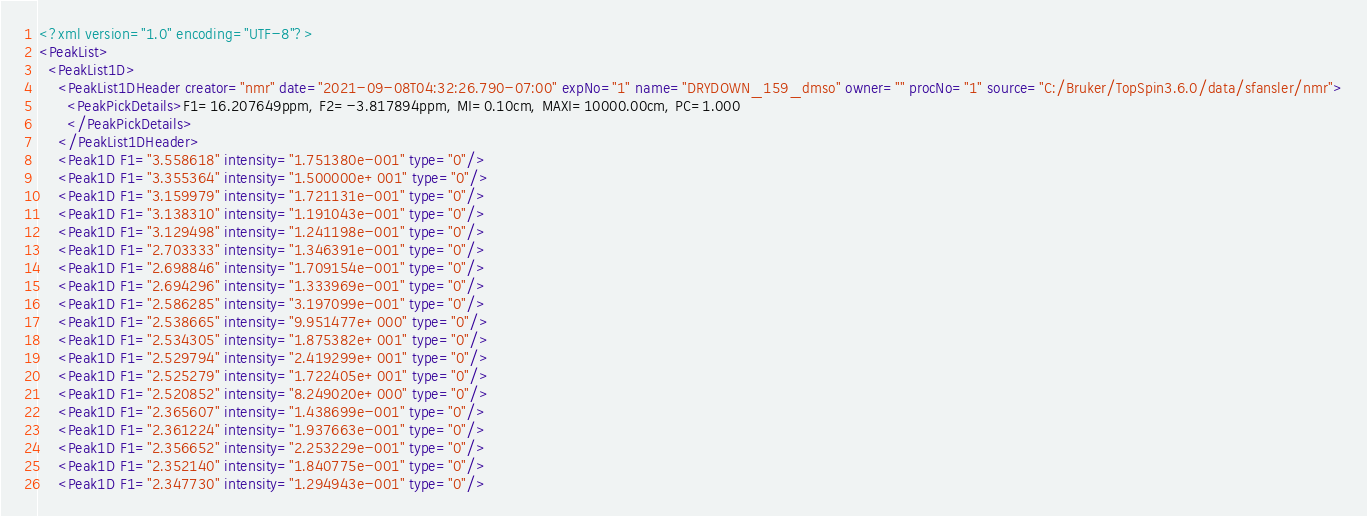Convert code to text. <code><loc_0><loc_0><loc_500><loc_500><_XML_><?xml version="1.0" encoding="UTF-8"?>
<PeakList>
  <PeakList1D>
    <PeakList1DHeader creator="nmr" date="2021-09-08T04:32:26.790-07:00" expNo="1" name="DRYDOWN_159_dmso" owner="" procNo="1" source="C:/Bruker/TopSpin3.6.0/data/sfansler/nmr">
      <PeakPickDetails>F1=16.207649ppm, F2=-3.817894ppm, MI=0.10cm, MAXI=10000.00cm, PC=1.000
      </PeakPickDetails>
    </PeakList1DHeader>
    <Peak1D F1="3.558618" intensity="1.751380e-001" type="0"/>
    <Peak1D F1="3.355364" intensity="1.500000e+001" type="0"/>
    <Peak1D F1="3.159979" intensity="1.721131e-001" type="0"/>
    <Peak1D F1="3.138310" intensity="1.191043e-001" type="0"/>
    <Peak1D F1="3.129498" intensity="1.241198e-001" type="0"/>
    <Peak1D F1="2.703333" intensity="1.346391e-001" type="0"/>
    <Peak1D F1="2.698846" intensity="1.709154e-001" type="0"/>
    <Peak1D F1="2.694296" intensity="1.333969e-001" type="0"/>
    <Peak1D F1="2.586285" intensity="3.197099e-001" type="0"/>
    <Peak1D F1="2.538665" intensity="9.951477e+000" type="0"/>
    <Peak1D F1="2.534305" intensity="1.875382e+001" type="0"/>
    <Peak1D F1="2.529794" intensity="2.419299e+001" type="0"/>
    <Peak1D F1="2.525279" intensity="1.722405e+001" type="0"/>
    <Peak1D F1="2.520852" intensity="8.249020e+000" type="0"/>
    <Peak1D F1="2.365607" intensity="1.438699e-001" type="0"/>
    <Peak1D F1="2.361224" intensity="1.937663e-001" type="0"/>
    <Peak1D F1="2.356652" intensity="2.253229e-001" type="0"/>
    <Peak1D F1="2.352140" intensity="1.840775e-001" type="0"/>
    <Peak1D F1="2.347730" intensity="1.294943e-001" type="0"/></code> 